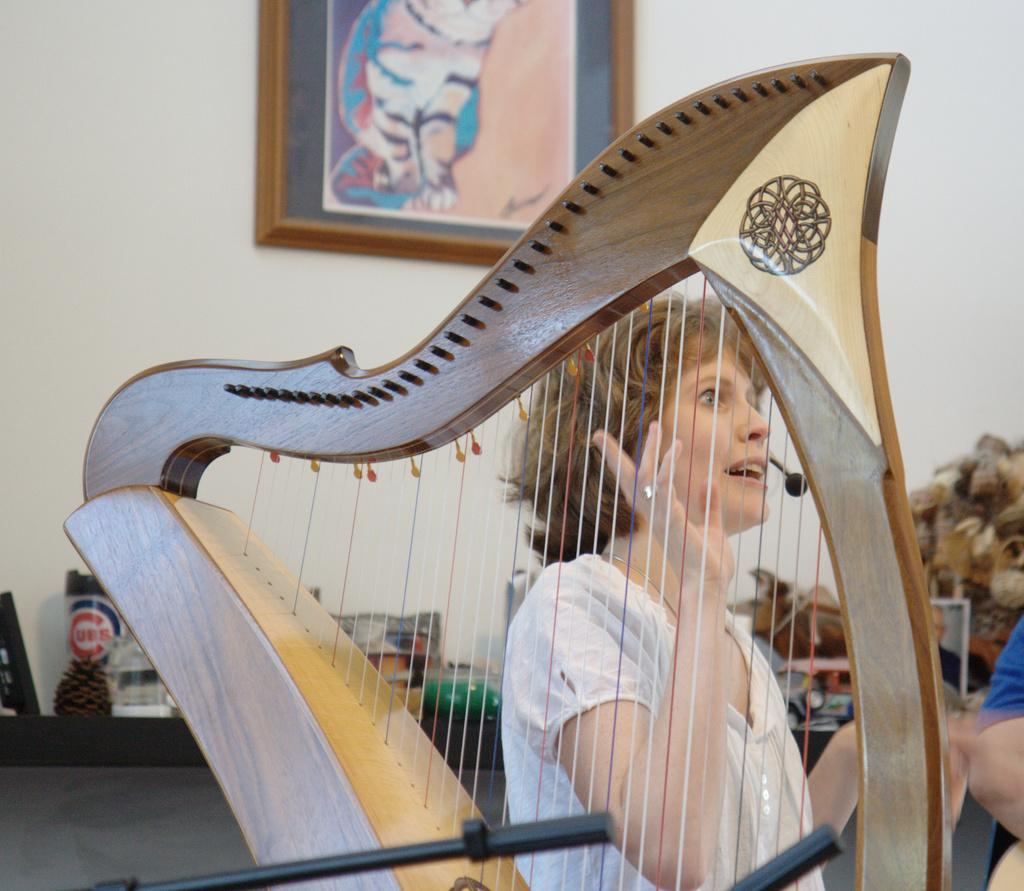Who or what is present in the image? There is a person in the image. What else can be seen in the image besides the person? There are objects in the image. Can you describe any specific features of the room or setting? There is a frame on the wall in the image. How many planes can be seen in the image? There are no planes visible in the image. What type of ticket is the person holding in the image? A: There is no ticket present in the image. 